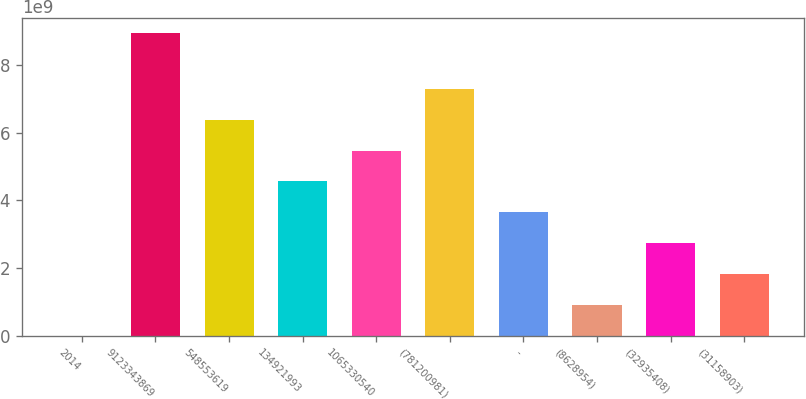<chart> <loc_0><loc_0><loc_500><loc_500><bar_chart><fcel>2014<fcel>9123343869<fcel>548553619<fcel>134921993<fcel>1065330540<fcel>(781200981)<fcel>-<fcel>(8628954)<fcel>(32935408)<fcel>(31158903)<nl><fcel>2013<fcel>8.94729e+09<fcel>6.38634e+09<fcel>4.56167e+09<fcel>5.47401e+09<fcel>7.29868e+09<fcel>3.64934e+09<fcel>9.12336e+08<fcel>2.737e+09<fcel>1.82467e+09<nl></chart> 